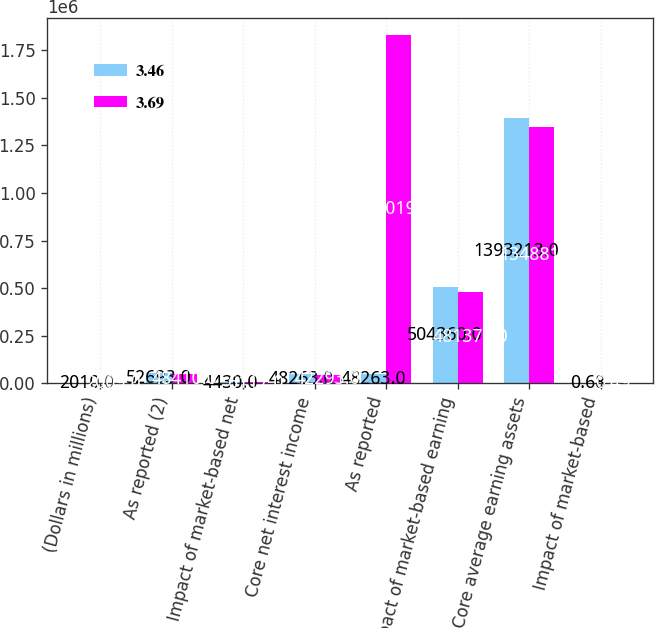Convert chart. <chart><loc_0><loc_0><loc_500><loc_500><stacked_bar_chart><ecel><fcel>(Dollars in millions)<fcel>As reported (2)<fcel>Impact of market-based net<fcel>Core net interest income<fcel>As reported<fcel>Impact of market-based earning<fcel>Core average earning assets<fcel>Impact of market-based<nl><fcel>3.46<fcel>2010<fcel>52693<fcel>4430<fcel>48263<fcel>48263<fcel>504360<fcel>1.39321e+06<fcel>0.68<nl><fcel>3.69<fcel>2009<fcel>48410<fcel>6117<fcel>42293<fcel>1.83019e+06<fcel>481376<fcel>1.34882e+06<fcel>0.49<nl></chart> 